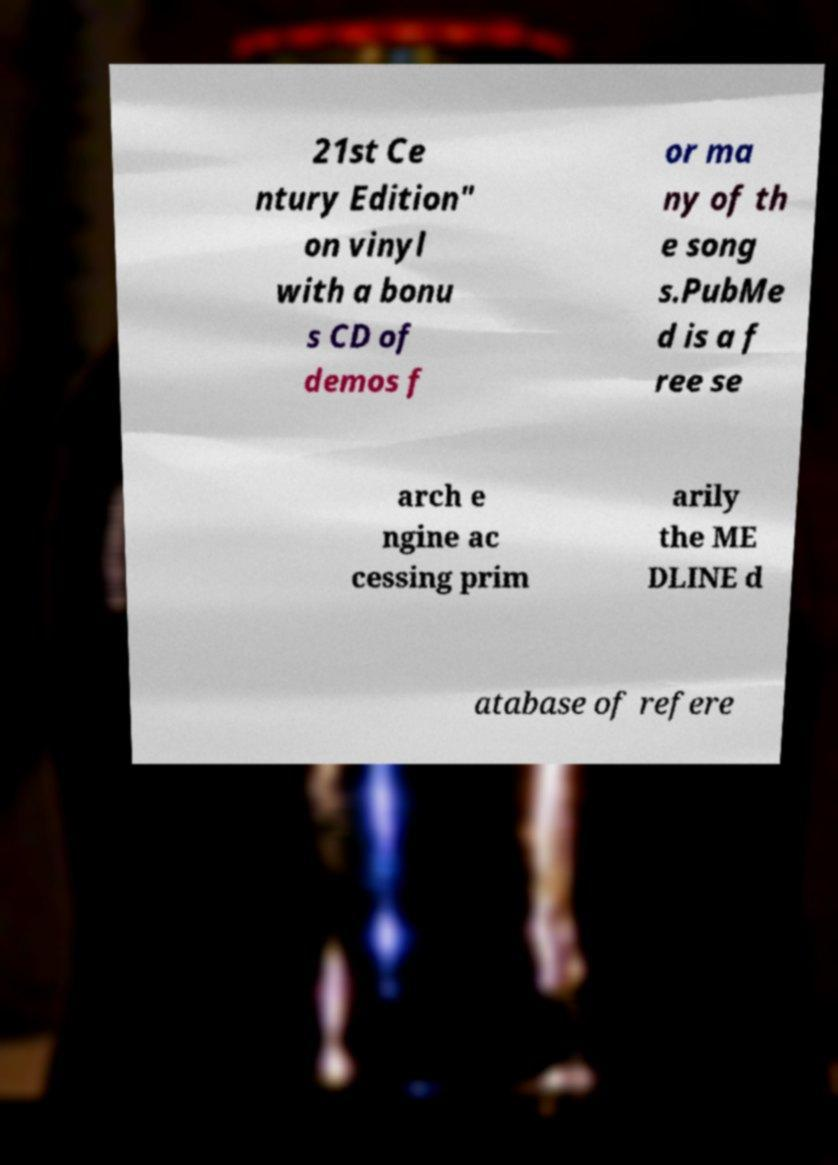What messages or text are displayed in this image? I need them in a readable, typed format. 21st Ce ntury Edition" on vinyl with a bonu s CD of demos f or ma ny of th e song s.PubMe d is a f ree se arch e ngine ac cessing prim arily the ME DLINE d atabase of refere 